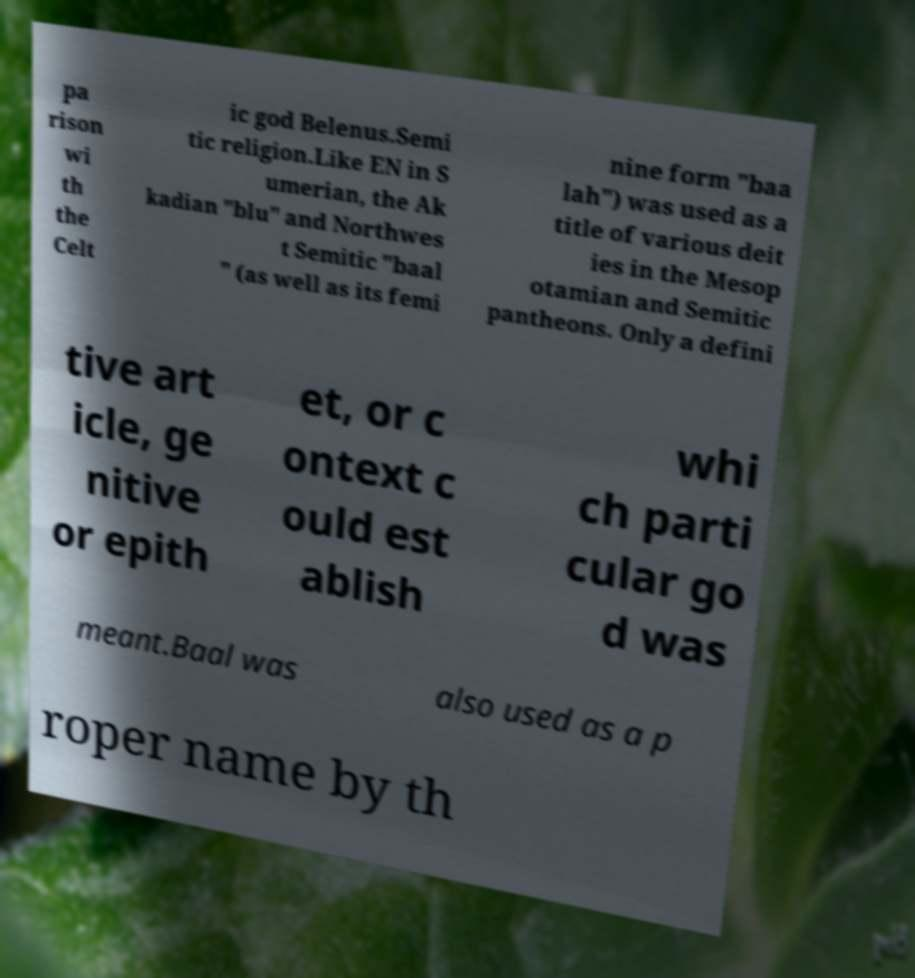Can you read and provide the text displayed in the image?This photo seems to have some interesting text. Can you extract and type it out for me? pa rison wi th the Celt ic god Belenus.Semi tic religion.Like EN in S umerian, the Ak kadian "blu" and Northwes t Semitic "baal " (as well as its femi nine form "baa lah") was used as a title of various deit ies in the Mesop otamian and Semitic pantheons. Only a defini tive art icle, ge nitive or epith et, or c ontext c ould est ablish whi ch parti cular go d was meant.Baal was also used as a p roper name by th 